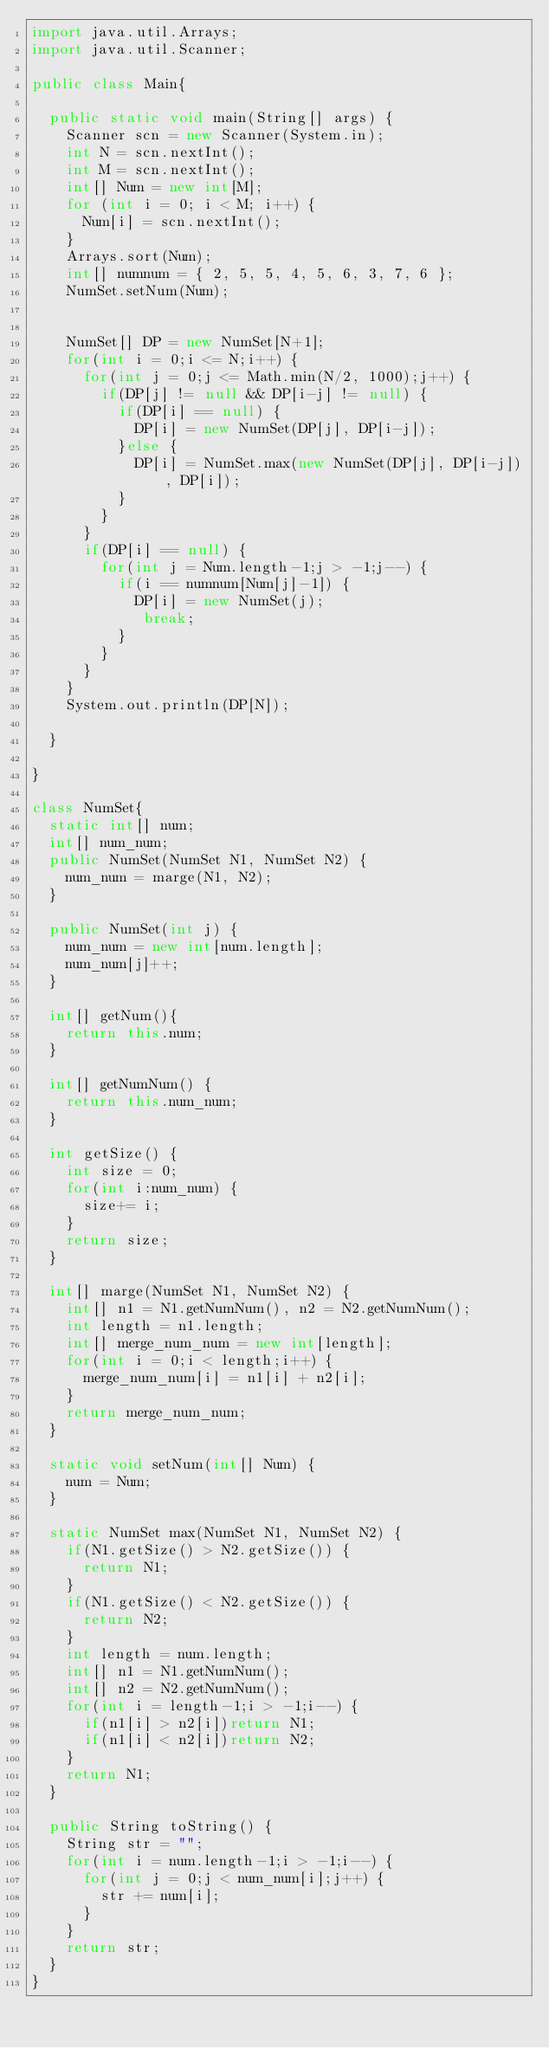<code> <loc_0><loc_0><loc_500><loc_500><_Java_>import java.util.Arrays;
import java.util.Scanner;

public class Main{

	public static void main(String[] args) {
		Scanner scn = new Scanner(System.in);
		int N = scn.nextInt();
		int M = scn.nextInt();
		int[] Num = new int[M];
		for (int i = 0; i < M; i++) {
			Num[i] = scn.nextInt();
		}
		Arrays.sort(Num);
		int[] numnum = { 2, 5, 5, 4, 5, 6, 3, 7, 6 };
		NumSet.setNum(Num);


		NumSet[] DP = new NumSet[N+1];
		for(int i = 0;i <= N;i++) {
			for(int j = 0;j <= Math.min(N/2, 1000);j++) {
				if(DP[j] != null && DP[i-j] != null) {
					if(DP[i] == null) {
						DP[i] = new NumSet(DP[j], DP[i-j]);
					}else {
						DP[i] = NumSet.max(new NumSet(DP[j], DP[i-j]), DP[i]);
					}
				}
			}
			if(DP[i] == null) {
				for(int j = Num.length-1;j > -1;j--) {
					if(i == numnum[Num[j]-1]) {
						DP[i] = new NumSet(j);
						 break;
					}
				}
			}
		}
		System.out.println(DP[N]);

	}

}

class NumSet{
	static int[] num;
	int[] num_num;
	public NumSet(NumSet N1, NumSet N2) {
		num_num = marge(N1, N2);
	}

	public NumSet(int j) {
		num_num = new int[num.length];
		num_num[j]++;
	}

	int[] getNum(){
		return this.num;
	}

	int[] getNumNum() {
		return this.num_num;
	}

	int getSize() {
		int size = 0;
		for(int i:num_num) {
			size+= i;
		}
		return size;
	}

	int[] marge(NumSet N1, NumSet N2) {
		int[] n1 = N1.getNumNum(), n2 = N2.getNumNum();
		int length = n1.length;
		int[] merge_num_num = new int[length];
		for(int i = 0;i < length;i++) {
			merge_num_num[i] = n1[i] + n2[i];
		}
		return merge_num_num;
	}

	static void setNum(int[] Num) {
		num = Num;
	}

	static NumSet max(NumSet N1, NumSet N2) {
		if(N1.getSize() > N2.getSize()) {
			return N1;
		}
		if(N1.getSize() < N2.getSize()) {
			return N2;
		}
		int length = num.length;
		int[] n1 = N1.getNumNum();
		int[] n2 = N2.getNumNum();
		for(int i = length-1;i > -1;i--) {
			if(n1[i] > n2[i])return N1;
			if(n1[i] < n2[i])return N2;
		}
		return N1;
	}

	public String toString() {
		String str = "";
		for(int i = num.length-1;i > -1;i--) {
			for(int j = 0;j < num_num[i];j++) {
				str += num[i];
			}
		}
		return str;
	}
}
</code> 